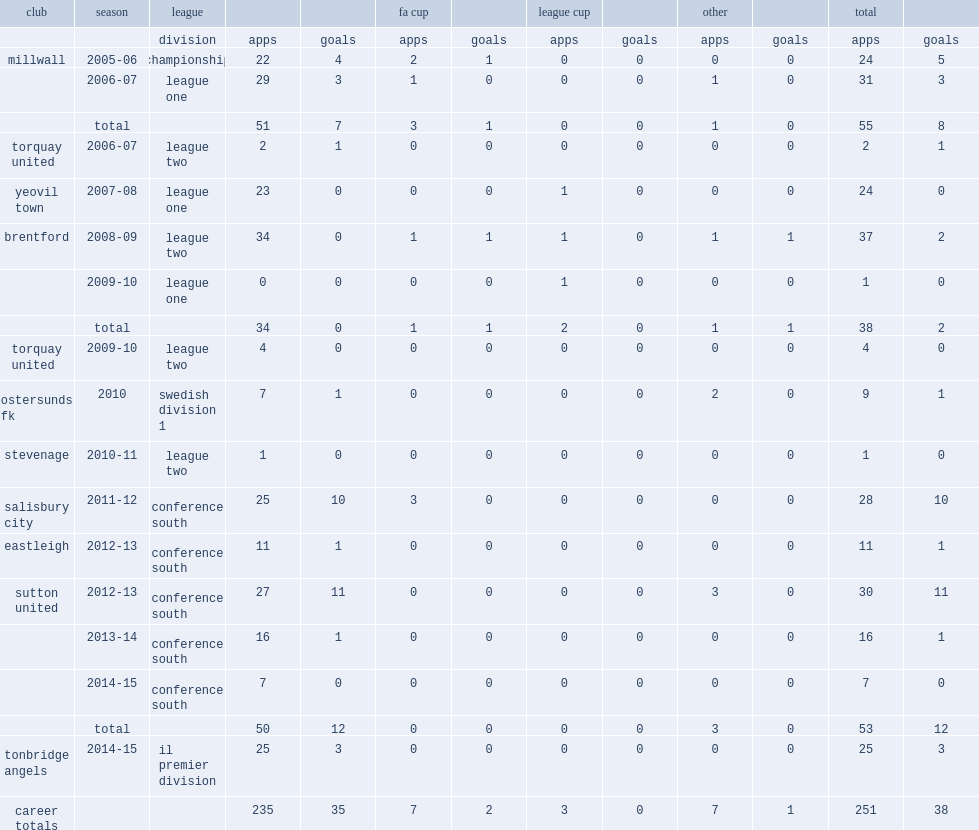Which club did williams play for in 2010-11? Stevenage. 